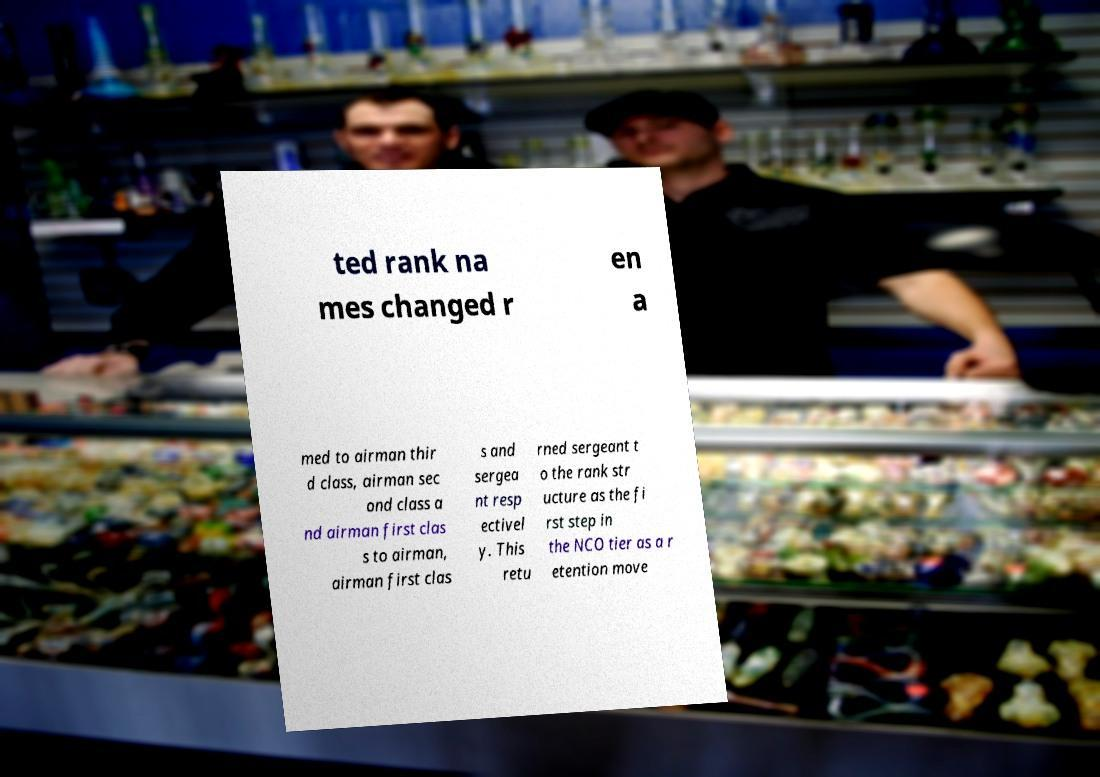Could you extract and type out the text from this image? ted rank na mes changed r en a med to airman thir d class, airman sec ond class a nd airman first clas s to airman, airman first clas s and sergea nt resp ectivel y. This retu rned sergeant t o the rank str ucture as the fi rst step in the NCO tier as a r etention move 